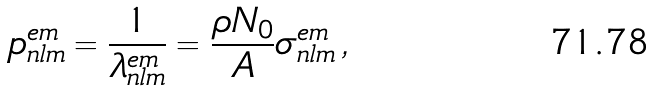Convert formula to latex. <formula><loc_0><loc_0><loc_500><loc_500>p _ { n l m } ^ { e m } = \frac { 1 } { \lambda _ { n l m } ^ { e m } } = \frac { \rho N _ { 0 } } { A } \sigma _ { n l m } ^ { e m } \, ,</formula> 